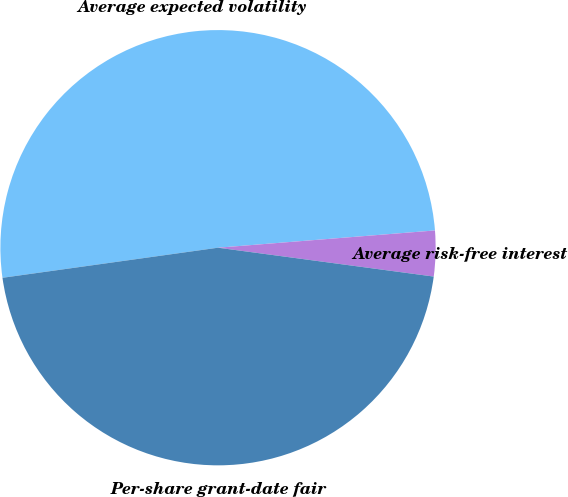Convert chart to OTSL. <chart><loc_0><loc_0><loc_500><loc_500><pie_chart><fcel>Average expected volatility<fcel>Average risk-free interest<fcel>Per-share grant-date fair<nl><fcel>50.94%<fcel>3.38%<fcel>45.67%<nl></chart> 